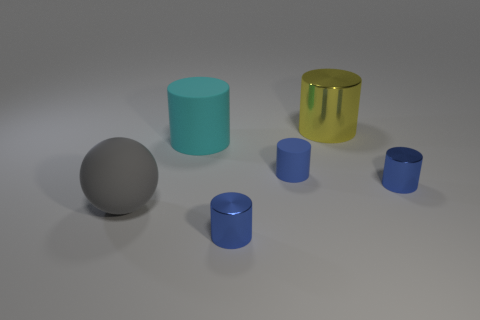Does the cyan cylinder have the same material as the yellow cylinder?
Ensure brevity in your answer.  No. Are there an equal number of tiny blue metallic cylinders that are to the left of the big ball and objects that are to the left of the yellow object?
Your response must be concise. No. What number of blue metal cylinders are behind the large yellow object?
Your answer should be compact. 0. How many objects are large cyan objects or metallic cylinders?
Your answer should be very brief. 4. How many yellow metallic cylinders have the same size as the gray ball?
Offer a terse response. 1. There is a shiny thing that is to the right of the shiny cylinder behind the cyan object; what shape is it?
Offer a very short reply. Cylinder. Is the number of large cylinders less than the number of large yellow cylinders?
Your answer should be very brief. No. What color is the tiny cylinder on the right side of the big yellow object?
Give a very brief answer. Blue. The large thing that is on the left side of the tiny blue matte cylinder and to the right of the rubber sphere is made of what material?
Provide a succinct answer. Rubber. What shape is the large cyan thing that is made of the same material as the gray ball?
Make the answer very short. Cylinder. 